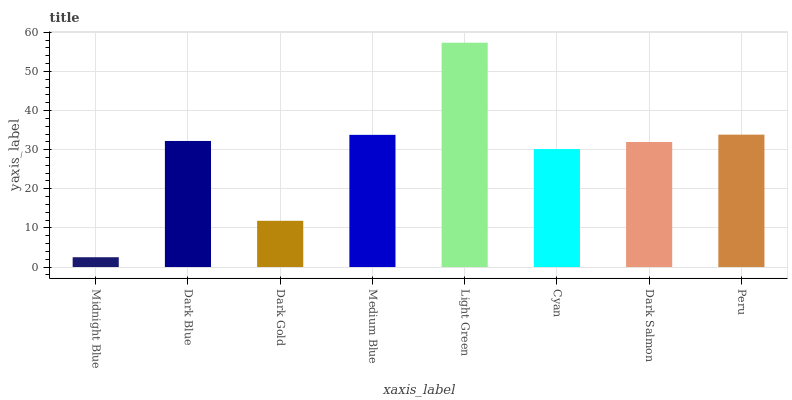Is Midnight Blue the minimum?
Answer yes or no. Yes. Is Light Green the maximum?
Answer yes or no. Yes. Is Dark Blue the minimum?
Answer yes or no. No. Is Dark Blue the maximum?
Answer yes or no. No. Is Dark Blue greater than Midnight Blue?
Answer yes or no. Yes. Is Midnight Blue less than Dark Blue?
Answer yes or no. Yes. Is Midnight Blue greater than Dark Blue?
Answer yes or no. No. Is Dark Blue less than Midnight Blue?
Answer yes or no. No. Is Dark Blue the high median?
Answer yes or no. Yes. Is Dark Salmon the low median?
Answer yes or no. Yes. Is Midnight Blue the high median?
Answer yes or no. No. Is Midnight Blue the low median?
Answer yes or no. No. 